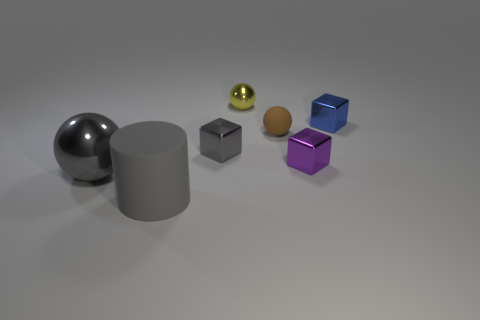Add 3 small brown balls. How many objects exist? 10 Subtract all blocks. How many objects are left? 4 Add 4 small yellow balls. How many small yellow balls exist? 5 Subtract 0 brown cubes. How many objects are left? 7 Subtract all big green metallic cubes. Subtract all big gray spheres. How many objects are left? 6 Add 7 tiny brown matte objects. How many tiny brown matte objects are left? 8 